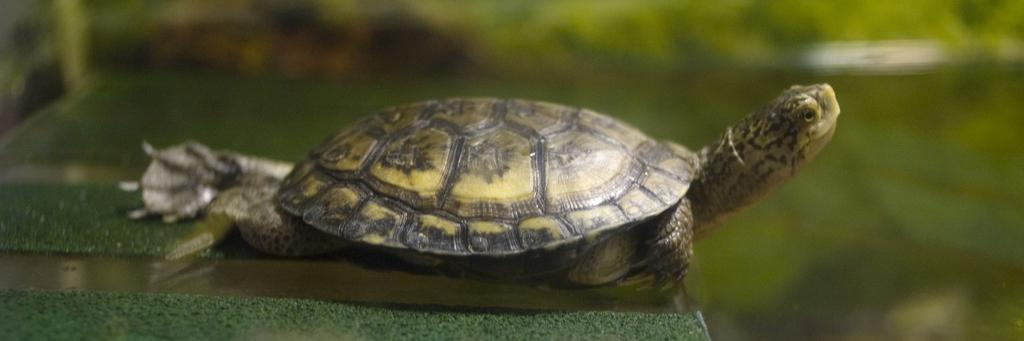What animal is present in the image? There is a tortoise in the image. What is the tortoise resting on? The tortoise is on a surface. Can you describe the background of the image? The background of the image is blurred. What type of cable can be seen connected to the tortoise in the image? There is no cable connected to the tortoise in the image. What vegetable is the tortoise holding in its mouth in the image? There is no vegetable, such as celery, present in the image. 